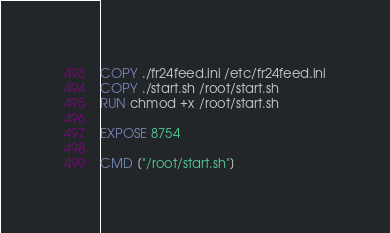Convert code to text. <code><loc_0><loc_0><loc_500><loc_500><_Dockerfile_>
COPY ./fr24feed.ini /etc/fr24feed.ini
COPY ./start.sh /root/start.sh
RUN chmod +x /root/start.sh

EXPOSE 8754

CMD ["/root/start.sh"]
</code> 